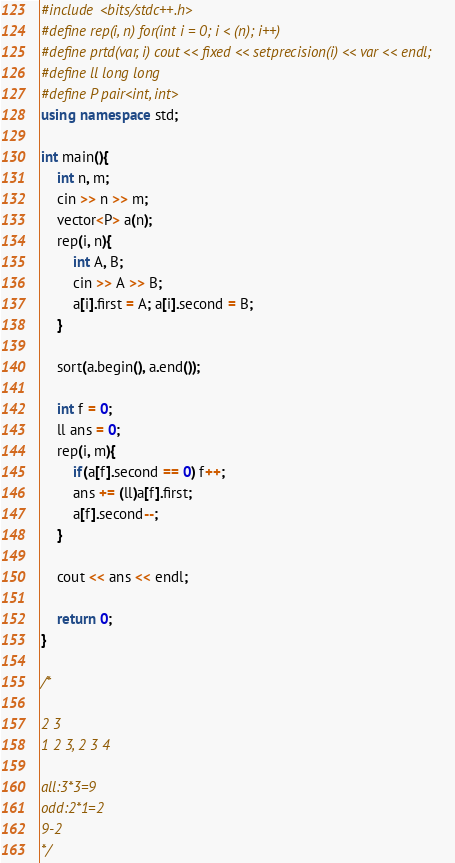<code> <loc_0><loc_0><loc_500><loc_500><_C++_>#include <bits/stdc++.h>
#define rep(i, n) for(int i = 0; i < (n); i++)
#define prtd(var, i) cout << fixed << setprecision(i) << var << endl;
#define ll long long
#define P pair<int, int>
using namespace std;

int main(){
    int n, m;
    cin >> n >> m;
    vector<P> a(n);
    rep(i, n){
        int A, B;
        cin >> A >> B;
        a[i].first = A; a[i].second = B;
    }

    sort(a.begin(), a.end());

    int f = 0;
    ll ans = 0;
    rep(i, m){
        if(a[f].second == 0) f++;
        ans += (ll)a[f].first;
        a[f].second--;
    }

    cout << ans << endl;

    return 0;
}   

/*

2 3
1 2 3, 2 3 4

all:3*3=9
odd:2*1=2
9-2
*/</code> 